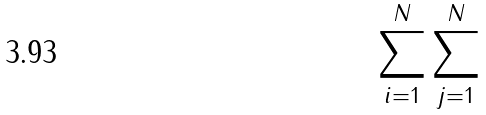<formula> <loc_0><loc_0><loc_500><loc_500>\sum _ { i = 1 } ^ { N } \sum _ { j = 1 } ^ { N }</formula> 